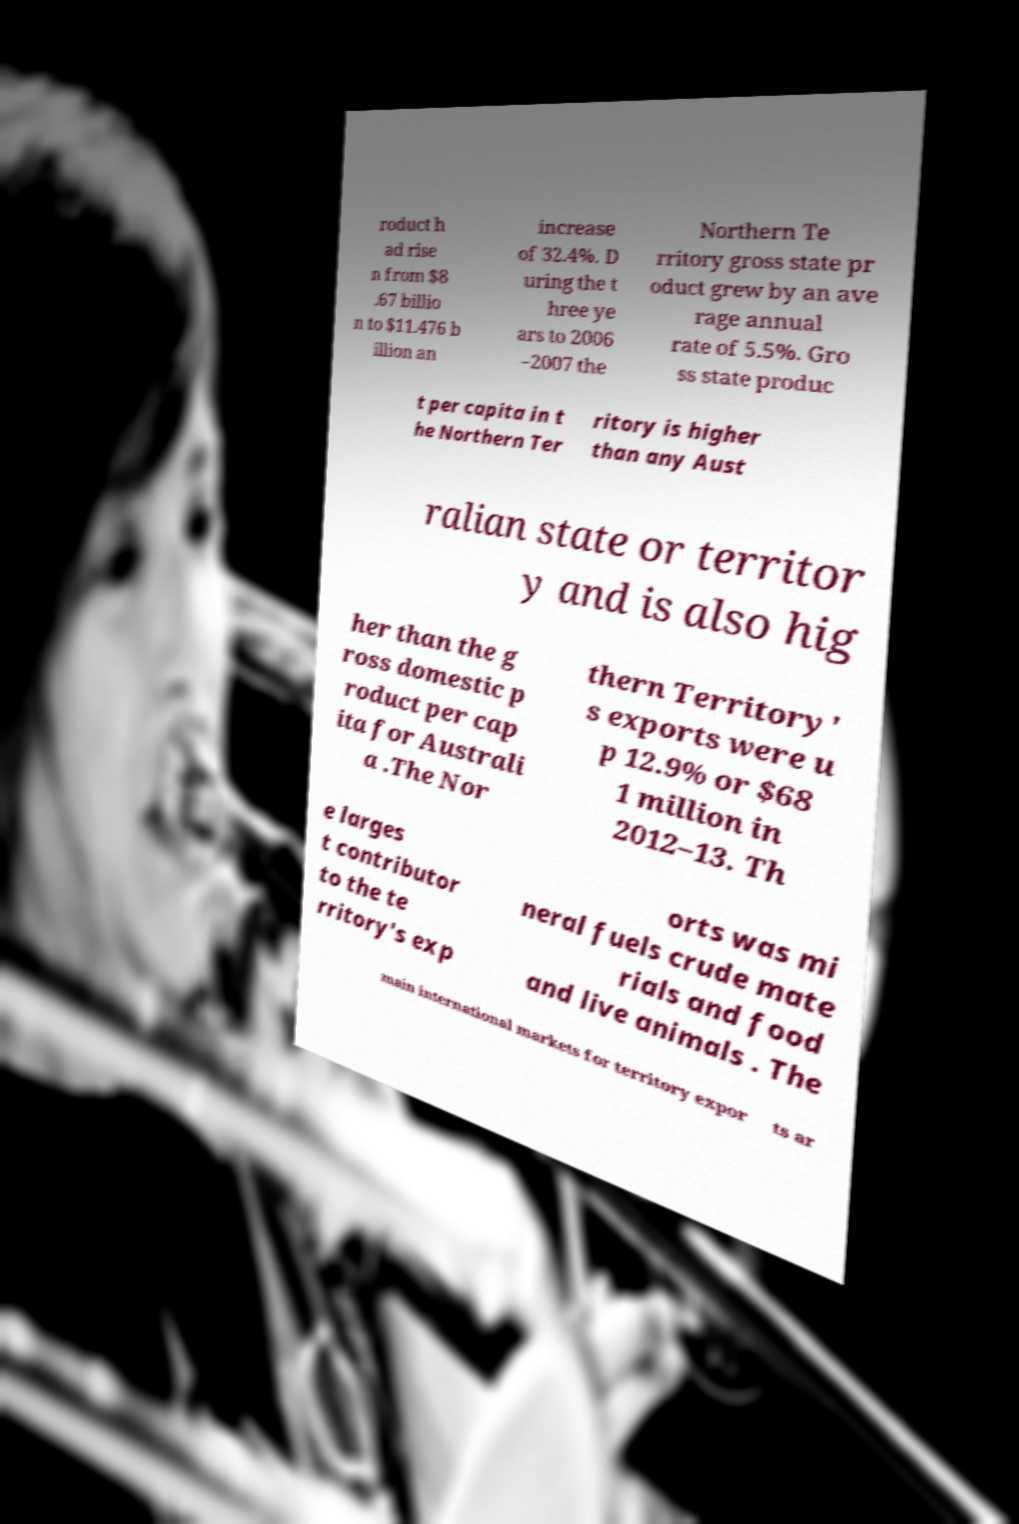Can you accurately transcribe the text from the provided image for me? roduct h ad rise n from $8 .67 billio n to $11.476 b illion an increase of 32.4%. D uring the t hree ye ars to 2006 –2007 the Northern Te rritory gross state pr oduct grew by an ave rage annual rate of 5.5%. Gro ss state produc t per capita in t he Northern Ter ritory is higher than any Aust ralian state or territor y and is also hig her than the g ross domestic p roduct per cap ita for Australi a .The Nor thern Territory' s exports were u p 12.9% or $68 1 million in 2012–13. Th e larges t contributor to the te rritory's exp orts was mi neral fuels crude mate rials and food and live animals . The main international markets for territory expor ts ar 